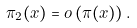<formula> <loc_0><loc_0><loc_500><loc_500>\pi _ { 2 } ( x ) = o \left ( \pi ( x ) \right ) .</formula> 